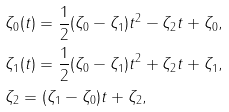<formula> <loc_0><loc_0><loc_500><loc_500>& \zeta _ { 0 } ( t ) = \frac { 1 } { 2 } ( \zeta _ { 0 } - \zeta _ { 1 } ) t ^ { 2 } - \zeta _ { 2 } t + \zeta _ { 0 } , \\ & \zeta _ { 1 } ( t ) = \frac { 1 } { 2 } ( \zeta _ { 0 } - \zeta _ { 1 } ) t ^ { 2 } + \zeta _ { 2 } t + \zeta _ { 1 } , \\ & \zeta _ { 2 } = ( \zeta _ { 1 } - \zeta _ { 0 } ) t + \zeta _ { 2 } ,</formula> 